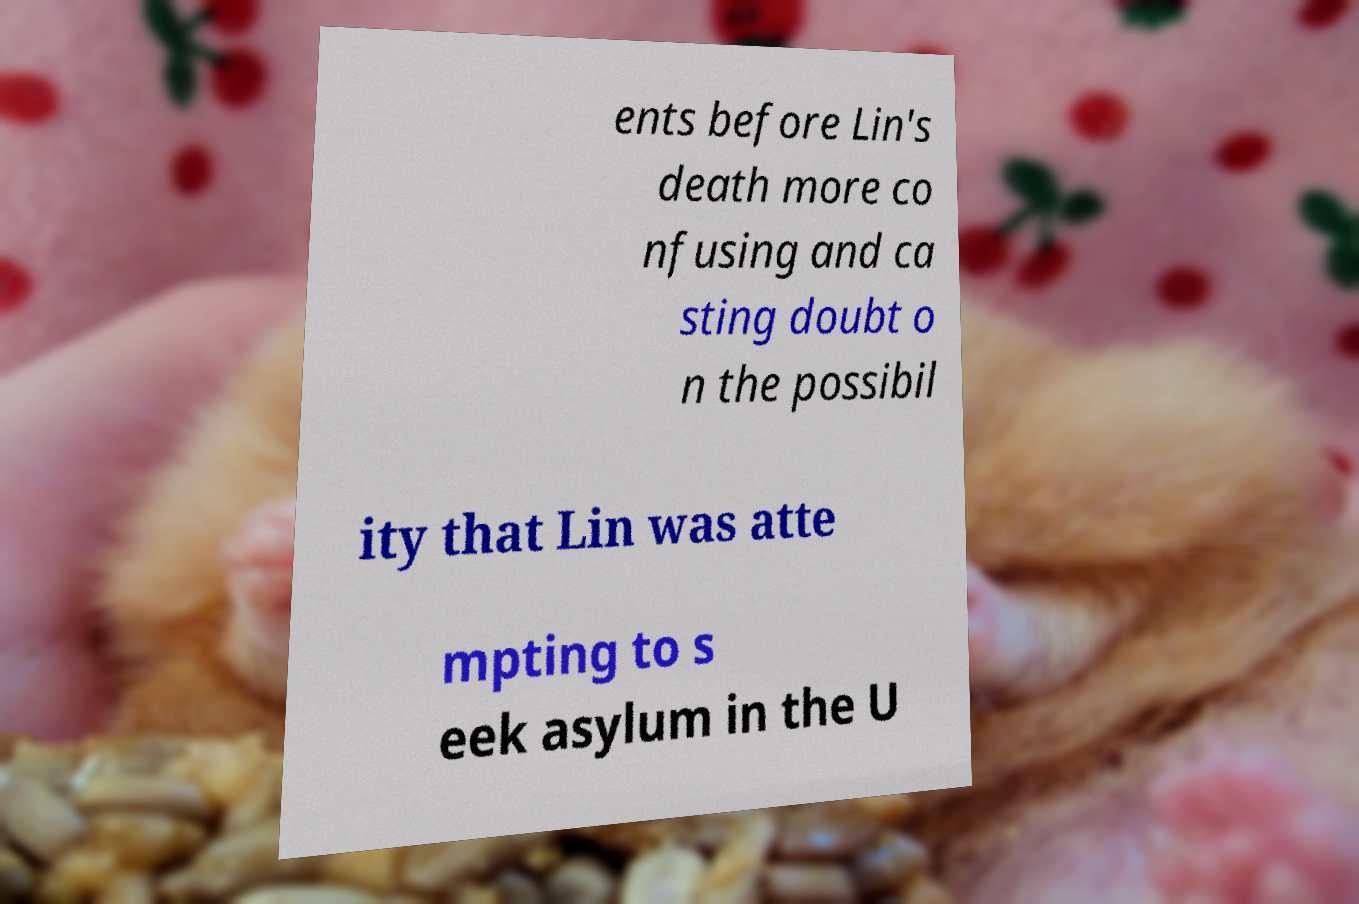There's text embedded in this image that I need extracted. Can you transcribe it verbatim? ents before Lin's death more co nfusing and ca sting doubt o n the possibil ity that Lin was atte mpting to s eek asylum in the U 